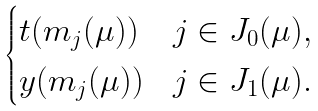<formula> <loc_0><loc_0><loc_500><loc_500>\begin{cases} t ( m _ { j } ( \mu ) ) & j \in J _ { 0 } ( \mu ) , \\ y ( m _ { j } ( \mu ) ) & j \in J _ { 1 } ( \mu ) . \end{cases}</formula> 